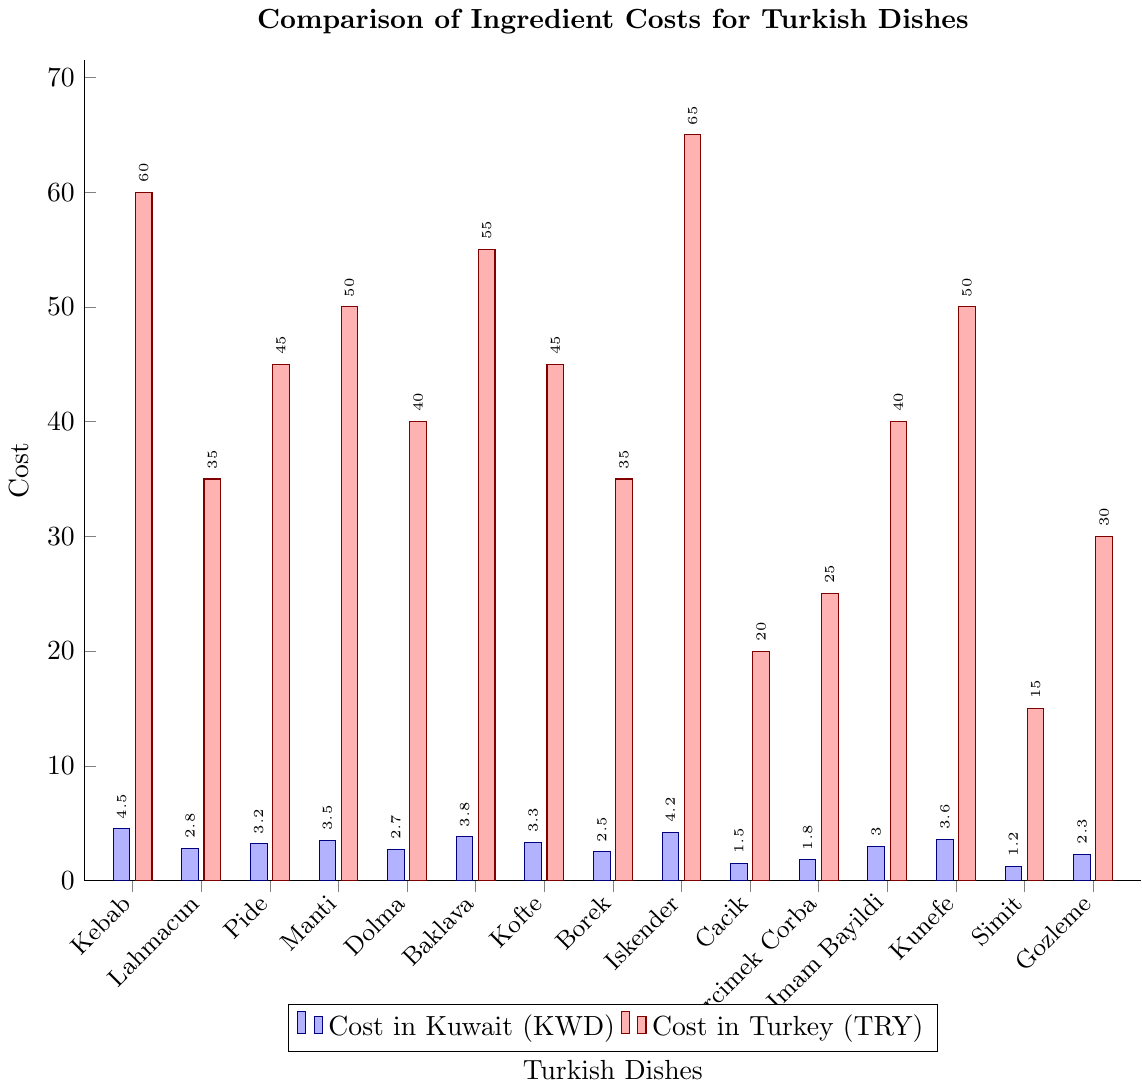Which dish has the highest cost in Kuwait? The dish with the highest cost in Kuwait is identified by the tallest blue bar in the figure. Among the dishes, "Kebab" has the highest cost in Kuwait at 4.5 KWD.
Answer: Kebab How does the cost of Kofte in Kuwait compare to its cost in Turkey? To find the cost comparison for Kofte, observe the height of the blue bar (Kuwait) and red bar (Turkey) for Kofte. The cost in Kuwait is 3.3 KWD while in Turkey it is 45 TRY. This means Kofte is more expensive in Turkey.
Answer: Kofte is cheaper in Kuwait What is the difference in cost for Mercimek Corba between Kuwait and Turkey? Subtract the cost in Kuwait (blue bar) from the cost in Turkey (red bar) for Mercimek Corba. The cost is 1.8 KWD in Kuwait and 25 TRY in Turkey.
Answer: 23.2 TRY Which dish has the smallest cost in Kuwait? The dish with the smallest cost in Kuwait is determined by the shortest blue bar. Among the dishes, "Simit" has the smallest cost at 1.2 KWD.
Answer: Simit What is the average cost of Pide and Lahmacun in Kuwait? Calculate the average by summing the costs of Pide (3.2 KWD) and Lahmacun (2.8 KWD) in Kuwait, and then dividing by 2. (3.2 + 2.8) / 2 = 3.0 KWD.
Answer: 3.0 KWD How much more does Iskender cost in Turkey compared to Kuwait? Subtract the cost in Kuwait (blue bar) from the cost in Turkey (red bar) for Iskender. The cost is 4.2 KWD in Kuwait and 65 TRY in Turkey.
Answer: 60.8 TRY Which two dishes have the same cost in Turkey, and what is that cost? Look for two red bars of equal height. Both Lahmacun and Borek have the same cost in Turkey, which is 35 TRY.
Answer: Lahmacun and Borek, 35 TRY What is the visual difference in height between the bars representing Baklava costs in Kuwait and Turkey? Compare the heights of the blue bar (Kuwait) and red bar (Turkey) for Baklava. The red bar is significantly taller. The numerical difference is 51.2 TRY.
Answer: The red bar (Turkey) is significantly taller Which dish has the largest cost difference between Kuwait and Turkey? Identify the dish with the largest numerical difference between the blue and red bars. Iskender has the largest cost difference, with 4.2 KWD in Kuwait and 65 TRY in Turkey, giving a difference of 60.8 TRY.
Answer: Iskender What's the median cost of the dishes in Kuwait? Organize the cost values in ascending order: 1.2, 1.5, 1.8, 2.3, 2.5, 2.7, 2.8, 3.0, 3.2, 3.3, 3.5, 3.6, 3.8, 4.2, 4.5. The median, or middle value, of these 15 dishes is 3.2 KWD.
Answer: 3.2 KWD 